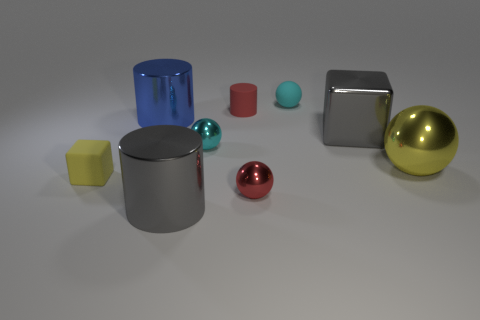What number of shiny blocks are the same color as the matte sphere? 0 